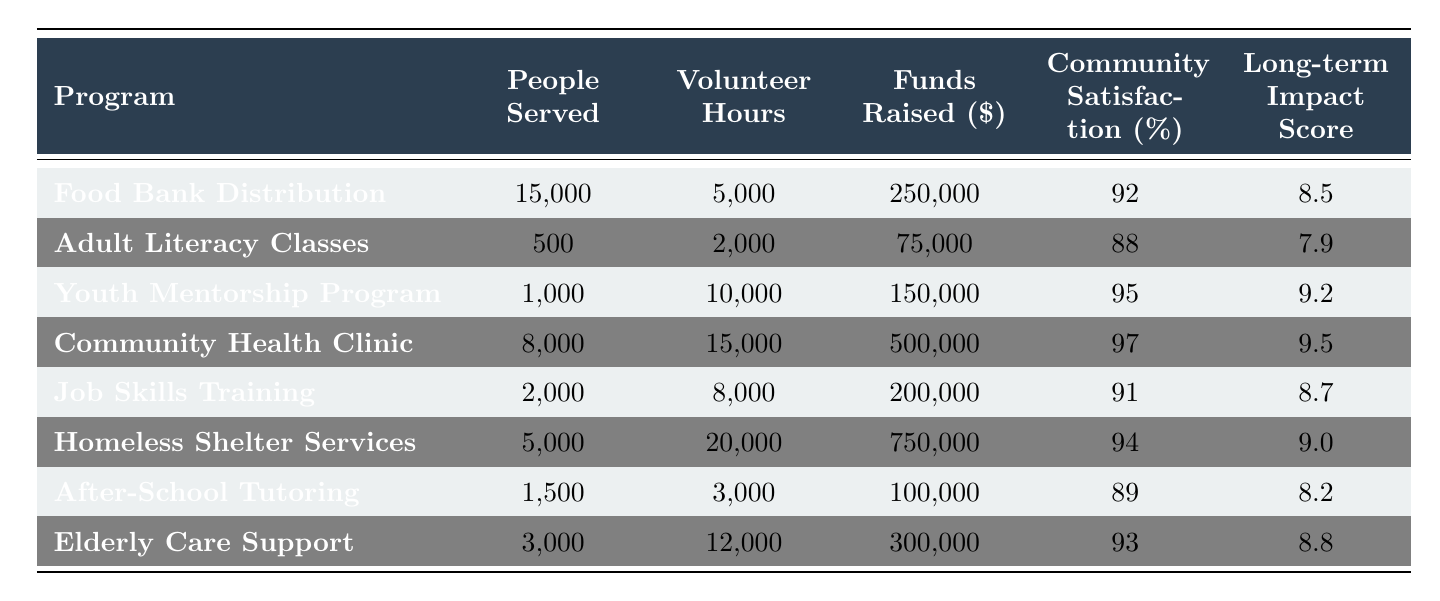What program served the most people? The "Food Bank Distribution" served 15,000 people, which is the highest value in the "People Served" column.
Answer: Food Bank Distribution Which program had the highest amount of volunteer hours? The "Homeless Shelter Services" had the highest amount of volunteer hours with 20,000 hours logged.
Answer: Homeless Shelter Services What is the average community satisfaction percentage across all programs? The satisfaction percentages are 92, 88, 95, 97, 91, 94, 89, and 93. Adding these gives  92+88+95+97+91+94+89+93 = 919; dividing by 8 gives an average of 919/8 = 114.875, therefore the average community satisfaction percentage is 91.7%.
Answer: 91.4% Is there a program that raised more than $500,000? Yes, the "Homeless Shelter Services" raised 750,000, which is more than 500,000.
Answer: Yes What is the difference in the long-term impact score between the "Community Health Clinic" and the "Adult Literacy Classes"? The long-term impact score for the "Community Health Clinic" is 9.5 and for the "Adult Literacy Classes" is 7.9. The difference is 9.5 - 7.9 = 1.6.
Answer: 1.6 Which program had both high volunteer hours and community satisfaction above 90%? The "Homeless Shelter Services" with 20,000 volunteer hours and 94% satisfaction and "Community Health Clinic" with 15,000 volunteer hours and 97% satisfaction fit this criterion.
Answer: Homeless Shelter Services, Community Health Clinic What is the total number of people served by all programs? The total number of people served can be calculated by summing: 15000 + 500 + 1000 + 8000 + 2000 + 5000 + 1500 + 3000 = 32000 people.
Answer: 32,000 Which program had the lowest long-term impact score? The "Adult Literacy Classes" had the lowest long-term impact score of 7.9 compared to all other programs.
Answer: Adult Literacy Classes Among the programs listed, how many served more than 5,000 people? The programs that served more than 5,000 people are "Food Bank Distribution," "Community Health Clinic," "Homeless Shelter Services," making a total of 3 programs.
Answer: 3 What is the total funds raised (in dollars) by the programs excluding "Youth Mentorship Program"? The total funds raised excluding "Youth Mentorship Program" is calculated as follows: 250,000 + 75,000 + 500,000 + 200,000 + 750,000 + 100,000 + 300,000 = 1,875,000 dollars.
Answer: 1,875,000 What percent of the volunteers contributed to the "Community Health Clinic"? The "Community Health Clinic" had 15,000 volunteer hours, compared to the total of 5,000 + 2,000 + 10,000 + 15,000 + 8,000 + 20,000 + 3,000 + 12,000 = 75,000. The percentage is (15,000 / 75,000) * 100 = 20%.
Answer: 20% 